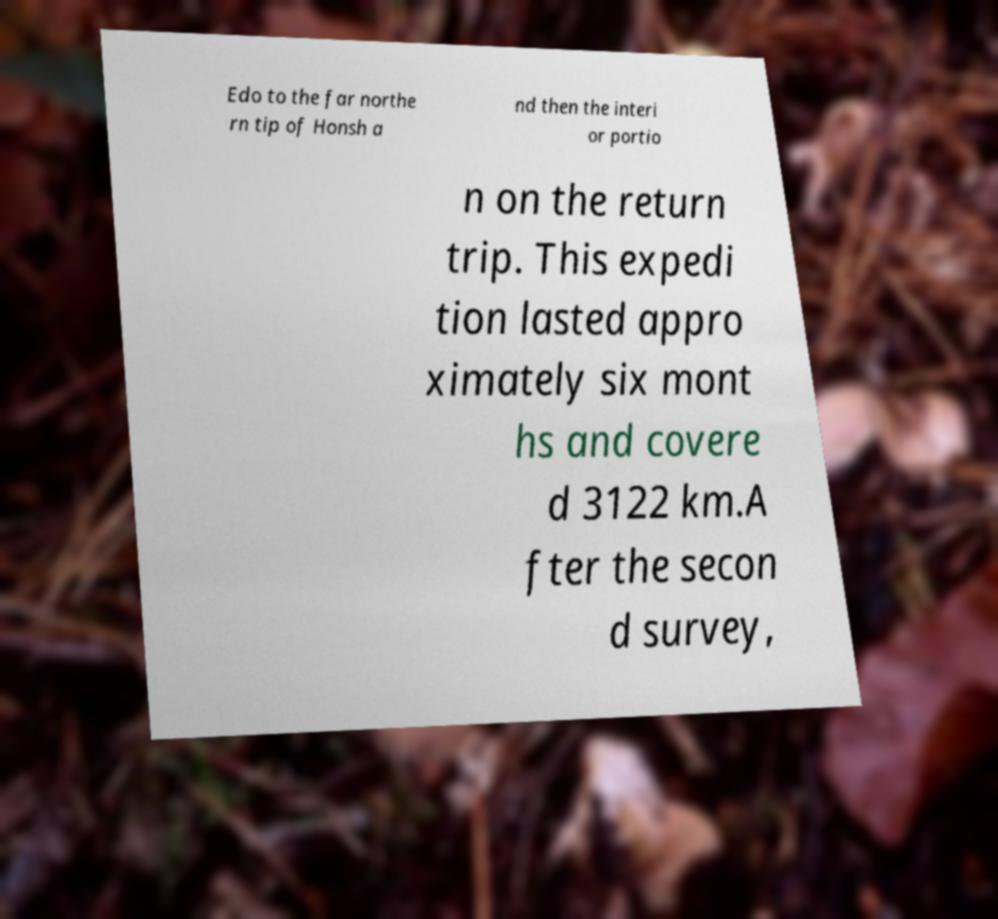I need the written content from this picture converted into text. Can you do that? Edo to the far northe rn tip of Honsh a nd then the interi or portio n on the return trip. This expedi tion lasted appro ximately six mont hs and covere d 3122 km.A fter the secon d survey, 